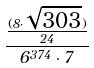<formula> <loc_0><loc_0><loc_500><loc_500>\frac { \frac { ( 8 \cdot \sqrt { 3 0 3 } ) } { 2 4 } } { 6 ^ { 3 7 4 } \cdot 7 }</formula> 